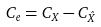Convert formula to latex. <formula><loc_0><loc_0><loc_500><loc_500>C _ { e } = C _ { X } - C _ { \hat { X } }</formula> 